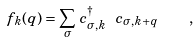<formula> <loc_0><loc_0><loc_500><loc_500>f _ { k } ( { q } ) = \sum _ { \sigma } \, c ^ { \dagger } _ { \sigma , { k } } \ c _ { \sigma , { k } + { q } } \quad ,</formula> 